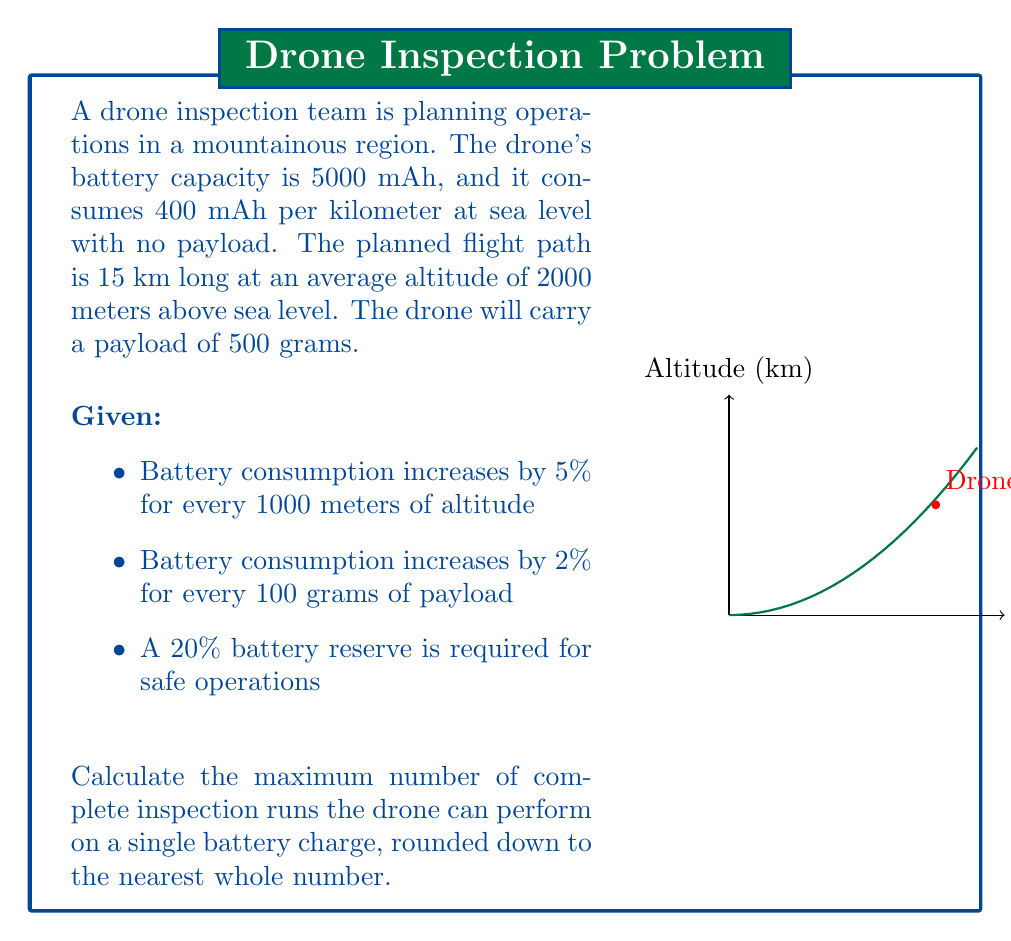Could you help me with this problem? Let's solve this problem step by step:

1) First, calculate the battery consumption increase due to altitude:
   $2000 \text{ m} \div 1000 \text{ m} \times 5\% = 10\%$ increase

2) Calculate the battery consumption increase due to payload:
   $500 \text{ g} \div 100 \text{ g} \times 2\% = 10\%$ increase

3) Total battery consumption increase:
   $10\% + 10\% = 20\%$ increase

4) Adjusted battery consumption per km:
   $400 \text{ mAh} \times 1.20 = 480 \text{ mAh/km}$

5) Total battery consumption for one 15 km run:
   $480 \text{ mAh/km} \times 15 \text{ km} = 7200 \text{ mAh}$

6) Available battery capacity considering 20% reserve:
   $5000 \text{ mAh} \times 0.80 = 4000 \text{ mAh}$

7) Number of complete runs possible:
   $4000 \text{ mAh} \div 7200 \text{ mAh/run} \approx 0.5556$ runs

8) Rounding down to the nearest whole number:
   $\lfloor 0.5556 \rfloor = 0$ complete runs

Therefore, the drone cannot complete a single full inspection run under these conditions while maintaining the required 20% battery reserve.
Answer: 0 complete runs 